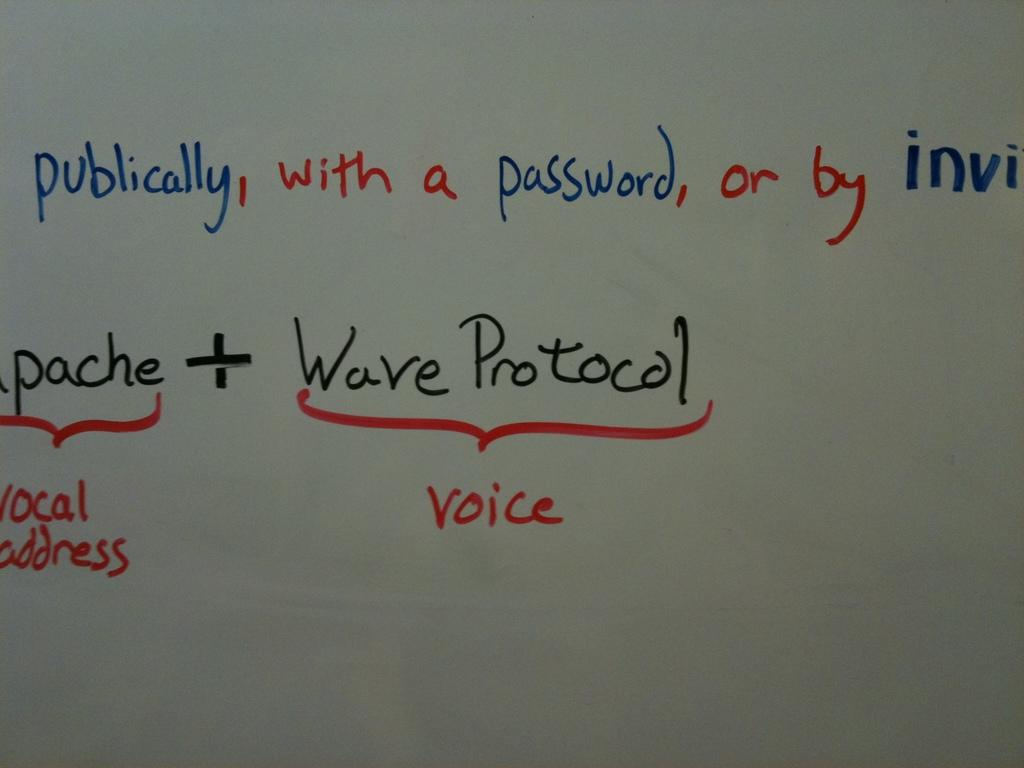What can be seen on a surface in the image? There is text visible on a surface in the image. Can you see a goat performing on a stage in the image? There is no goat or stage present in the image; only text visible on a surface is mentioned. 